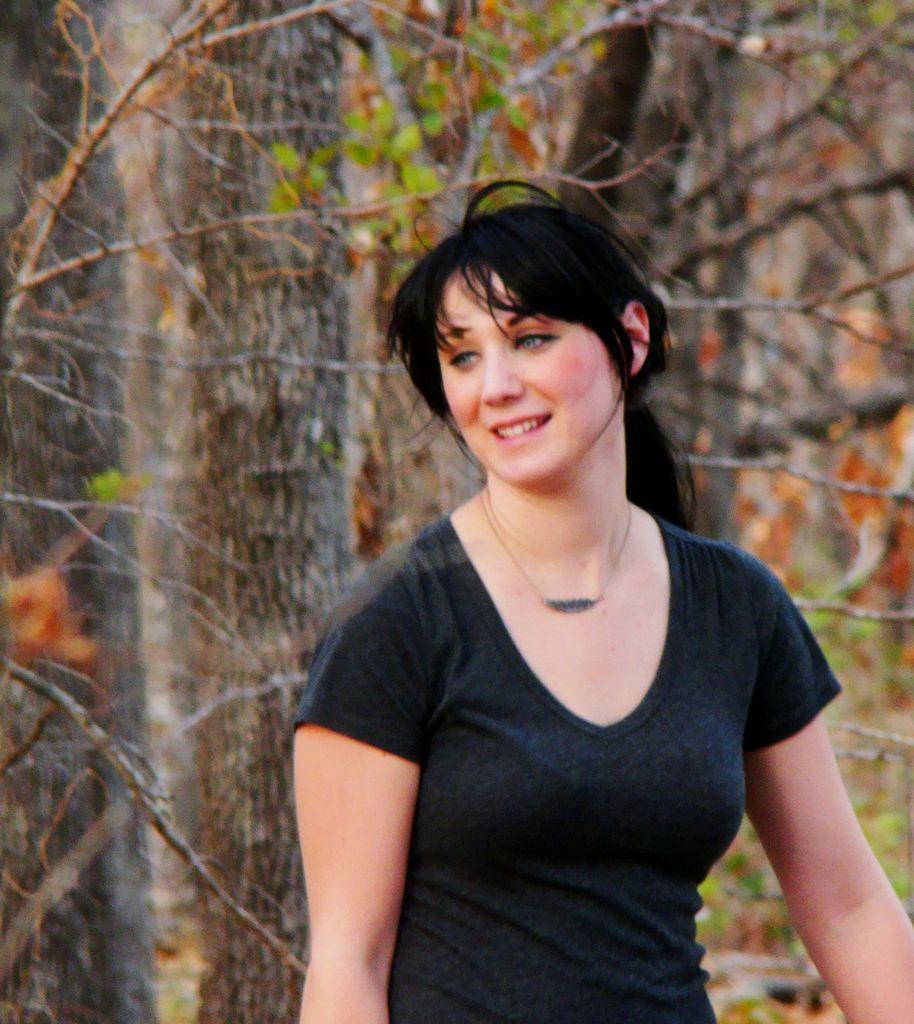Who is present in the image? There is a woman in the image. What is the woman's facial expression? The woman is smiling. Can you describe the background of the image? The background of the image is blurry, and there are branches and leaves present. What type of twig is the woman holding in the image? There is no twig visible in the image. The woman is not holding any object, and the focus is on her smiling expression. 